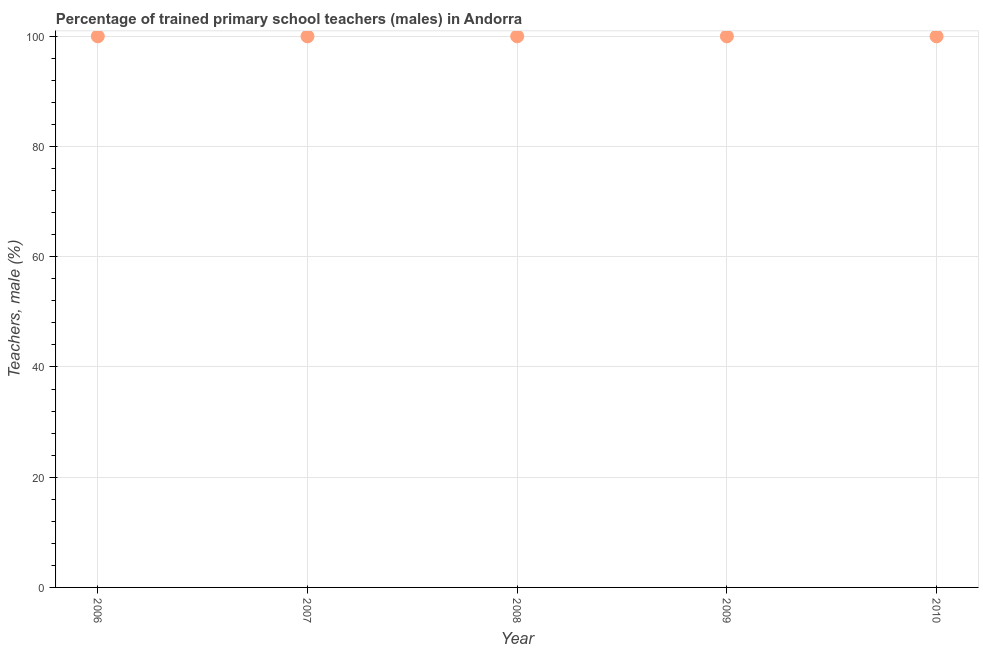What is the percentage of trained male teachers in 2007?
Keep it short and to the point. 100. Across all years, what is the maximum percentage of trained male teachers?
Your answer should be very brief. 100. Across all years, what is the minimum percentage of trained male teachers?
Give a very brief answer. 100. In which year was the percentage of trained male teachers maximum?
Your answer should be very brief. 2006. What is the sum of the percentage of trained male teachers?
Provide a succinct answer. 500. What is the difference between the percentage of trained male teachers in 2008 and 2010?
Offer a terse response. 0. What is the average percentage of trained male teachers per year?
Your answer should be very brief. 100. What is the median percentage of trained male teachers?
Your answer should be very brief. 100. In how many years, is the percentage of trained male teachers greater than 48 %?
Your answer should be compact. 5. Is the percentage of trained male teachers in 2006 less than that in 2007?
Provide a short and direct response. No. Is the difference between the percentage of trained male teachers in 2006 and 2010 greater than the difference between any two years?
Your answer should be very brief. Yes. What is the difference between the highest and the second highest percentage of trained male teachers?
Make the answer very short. 0. Is the sum of the percentage of trained male teachers in 2006 and 2008 greater than the maximum percentage of trained male teachers across all years?
Ensure brevity in your answer.  Yes. What is the difference between the highest and the lowest percentage of trained male teachers?
Your answer should be very brief. 0. In how many years, is the percentage of trained male teachers greater than the average percentage of trained male teachers taken over all years?
Make the answer very short. 0. Does the percentage of trained male teachers monotonically increase over the years?
Your answer should be compact. No. What is the title of the graph?
Keep it short and to the point. Percentage of trained primary school teachers (males) in Andorra. What is the label or title of the X-axis?
Your answer should be very brief. Year. What is the label or title of the Y-axis?
Offer a very short reply. Teachers, male (%). What is the Teachers, male (%) in 2010?
Give a very brief answer. 100. What is the difference between the Teachers, male (%) in 2006 and 2007?
Offer a terse response. 0. What is the difference between the Teachers, male (%) in 2006 and 2008?
Your answer should be very brief. 0. What is the difference between the Teachers, male (%) in 2006 and 2010?
Give a very brief answer. 0. What is the difference between the Teachers, male (%) in 2007 and 2009?
Your answer should be very brief. 0. What is the difference between the Teachers, male (%) in 2008 and 2010?
Ensure brevity in your answer.  0. What is the ratio of the Teachers, male (%) in 2006 to that in 2008?
Ensure brevity in your answer.  1. What is the ratio of the Teachers, male (%) in 2006 to that in 2009?
Your response must be concise. 1. What is the ratio of the Teachers, male (%) in 2006 to that in 2010?
Provide a succinct answer. 1. What is the ratio of the Teachers, male (%) in 2007 to that in 2009?
Offer a very short reply. 1. What is the ratio of the Teachers, male (%) in 2008 to that in 2009?
Keep it short and to the point. 1. 